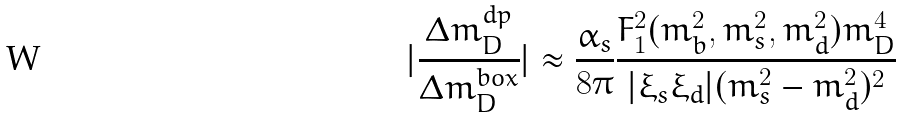Convert formula to latex. <formula><loc_0><loc_0><loc_500><loc_500>| \frac { \Delta m _ { D } ^ { d p } } { \Delta m _ { D } ^ { b o x } } | \approx \frac { \alpha _ { s } } { 8 \pi } \frac { F _ { 1 } ^ { 2 } ( m _ { b } ^ { 2 } , m _ { s } ^ { 2 } , m _ { d } ^ { 2 } ) m _ { D } ^ { 4 } } { | \xi _ { s } \xi _ { d } | ( m _ { s } ^ { 2 } - m _ { d } ^ { 2 } ) ^ { 2 } }</formula> 